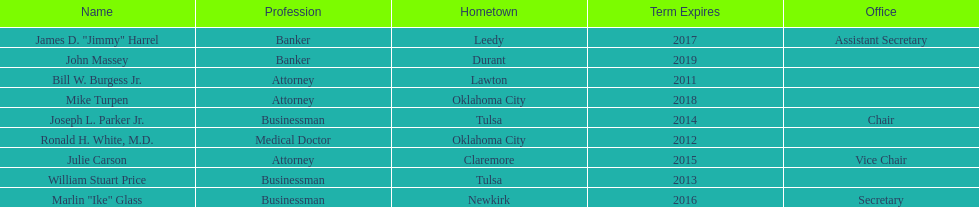Which state regent is from the same hometown as ronald h. white, m.d.? Mike Turpen. 